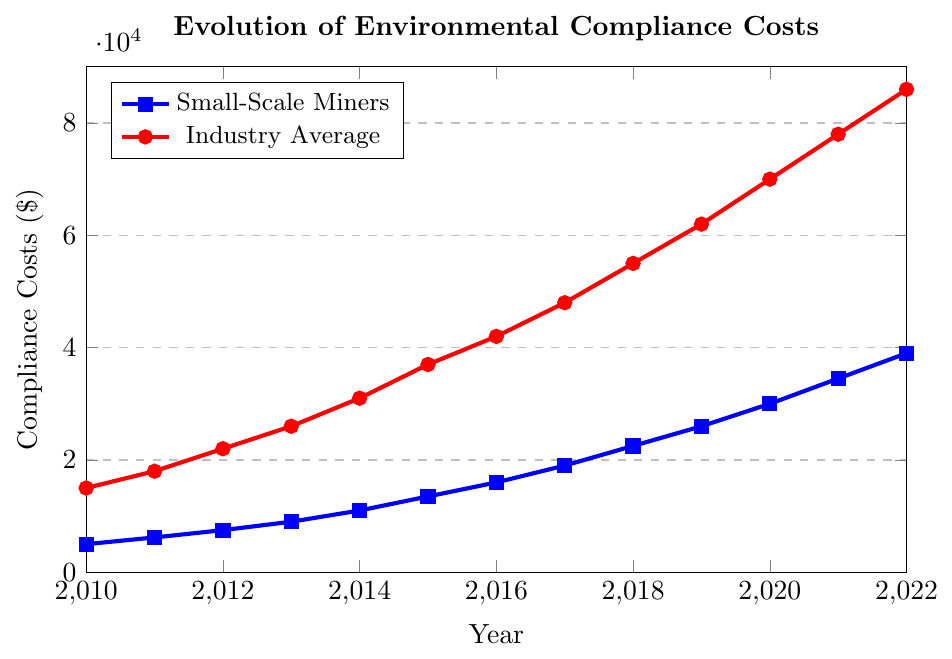What is the compliance cost for small-scale miners in 2013? Refer to the blue line with square markers, corresponding to the year 2013. The cost is 9000 dollars.
Answer: 9000 dollars How much did the compliance cost for small-scale miners increase from 2010 to 2012? Subtract the 2010 cost from the 2012 cost. (7500 - 5000 = 2500)
Answer: 2500 dollars By what amount did the industry average compliance cost exceed small-scale miners' compliance costs in 2022? Subtract the small-scale miners' cost from the industry average cost in 2022. (86000 - 39000 = 47000)
Answer: 47000 dollars In which year did the compliance cost for small-scale miners first exceed 10000 dollars? Look at the blue line and find the first year when the cost surpasses 10000 dollars, which occurs in 2014.
Answer: 2014 What is the average compliance cost for small-scale miners over the years 2010 to 2022? Sum all the compliance costs for small-scale miners from 2010 to 2022 and then divide by the number of years. (5000 + 6200 + 7500 + 9000 + 11000 + 13500 + 16000 + 19000 + 22500 + 26000 + 30000 + 34500 + 39000) / 13 = 18923.08
Answer: 18923.08 dollars How much did industry average compliance costs increase from 2020 to 2022? Subtract the 2020 cost from the 2022 cost. (86000 - 70000 = 16000)
Answer: 16000 dollars Which year showed the highest compliance costs for small-scale miners? Identify the peak value on the blue line and the corresponding year, which is 2022 with 39000 dollars.
Answer: 2022 How much did small-scale miners' compliance costs change between 2016 and 2019? Find the difference between the 2019 cost and the 2016 cost. (26000 - 16000 = 10000)
Answer: 10000 dollars What is the ratio of industry average compliance costs to small-scale miners' compliance costs in 2011? Divide the industry average cost by the small-scale miners' cost for 2011. (18000 / 6200 ≈ 2.90)
Answer: 2.90 By how much did the compliance costs for small-scale miners increase in 2021 compared to the previous year, 2020? Subtract the 2020 cost from the 2021 cost. (34500 - 30000 = 4500)
Answer: 4500 dollars 